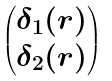<formula> <loc_0><loc_0><loc_500><loc_500>\begin{pmatrix} \delta _ { 1 } ( r ) \\ \delta _ { 2 } ( r ) \end{pmatrix}</formula> 